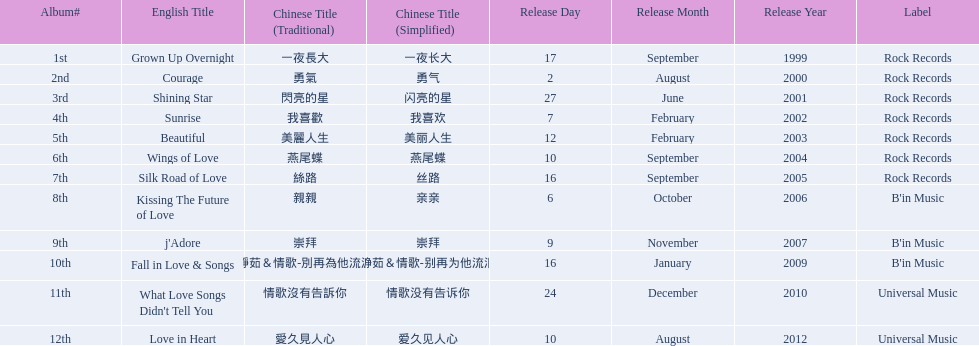What songs were on b'in music or universal music? Kissing The Future of Love, j'Adore, Fall in Love & Songs, What Love Songs Didn't Tell You, Love in Heart. 